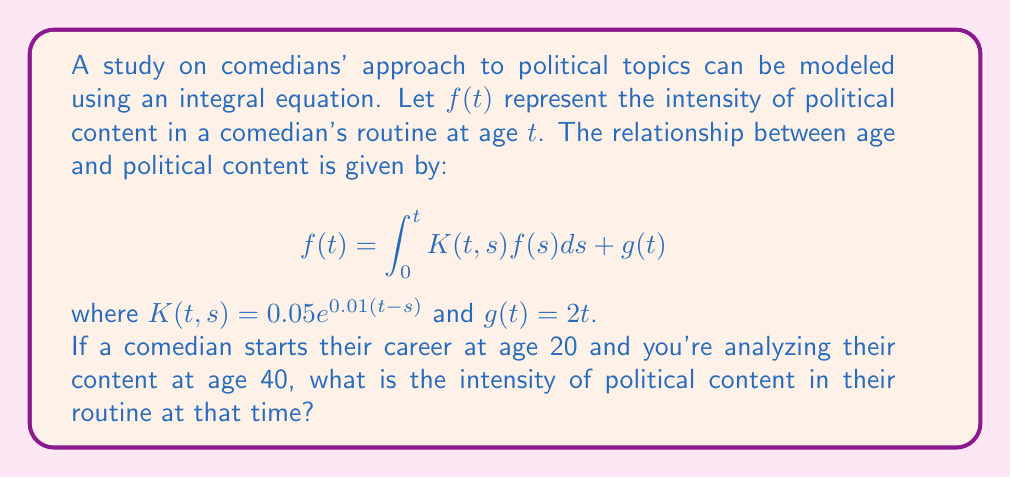Can you answer this question? To solve this integral equation, we'll use the method of successive approximations:

1) Start with an initial approximation: $f_0(t) = g(t) = 2t$

2) Use the recurrence relation:
   $$f_{n+1}(t) = \int_0^t K(t,s)f_n(s)ds + g(t)$$

3) Calculate $f_1(t)$:
   $$f_1(t) = \int_0^t 0.05e^{0.01(t-s)}(2s)ds + 2t$$
   $$= 0.1e^{0.01t}\int_0^t se^{-0.01s}ds + 2t$$
   $$= 0.1e^{0.01t}[-100se^{-0.01s} - 10000e^{-0.01s}]_0^t + 2t$$
   $$= 0.1e^{0.01t}(-100te^{-0.01t} - 10000e^{-0.01t} + 10000) + 2t$$
   $$= -10t - 1000 + 1000e^{0.01t} + 2t$$
   $$= -8t - 1000 + 1000e^{0.01t}$$

4) For $t = 40$:
   $$f_1(40) = -320 - 1000 + 1000e^{0.4} \approx 173.89$$

5) We could continue this process for more accurate results, but let's stop at this approximation.
Answer: $173.89$ 